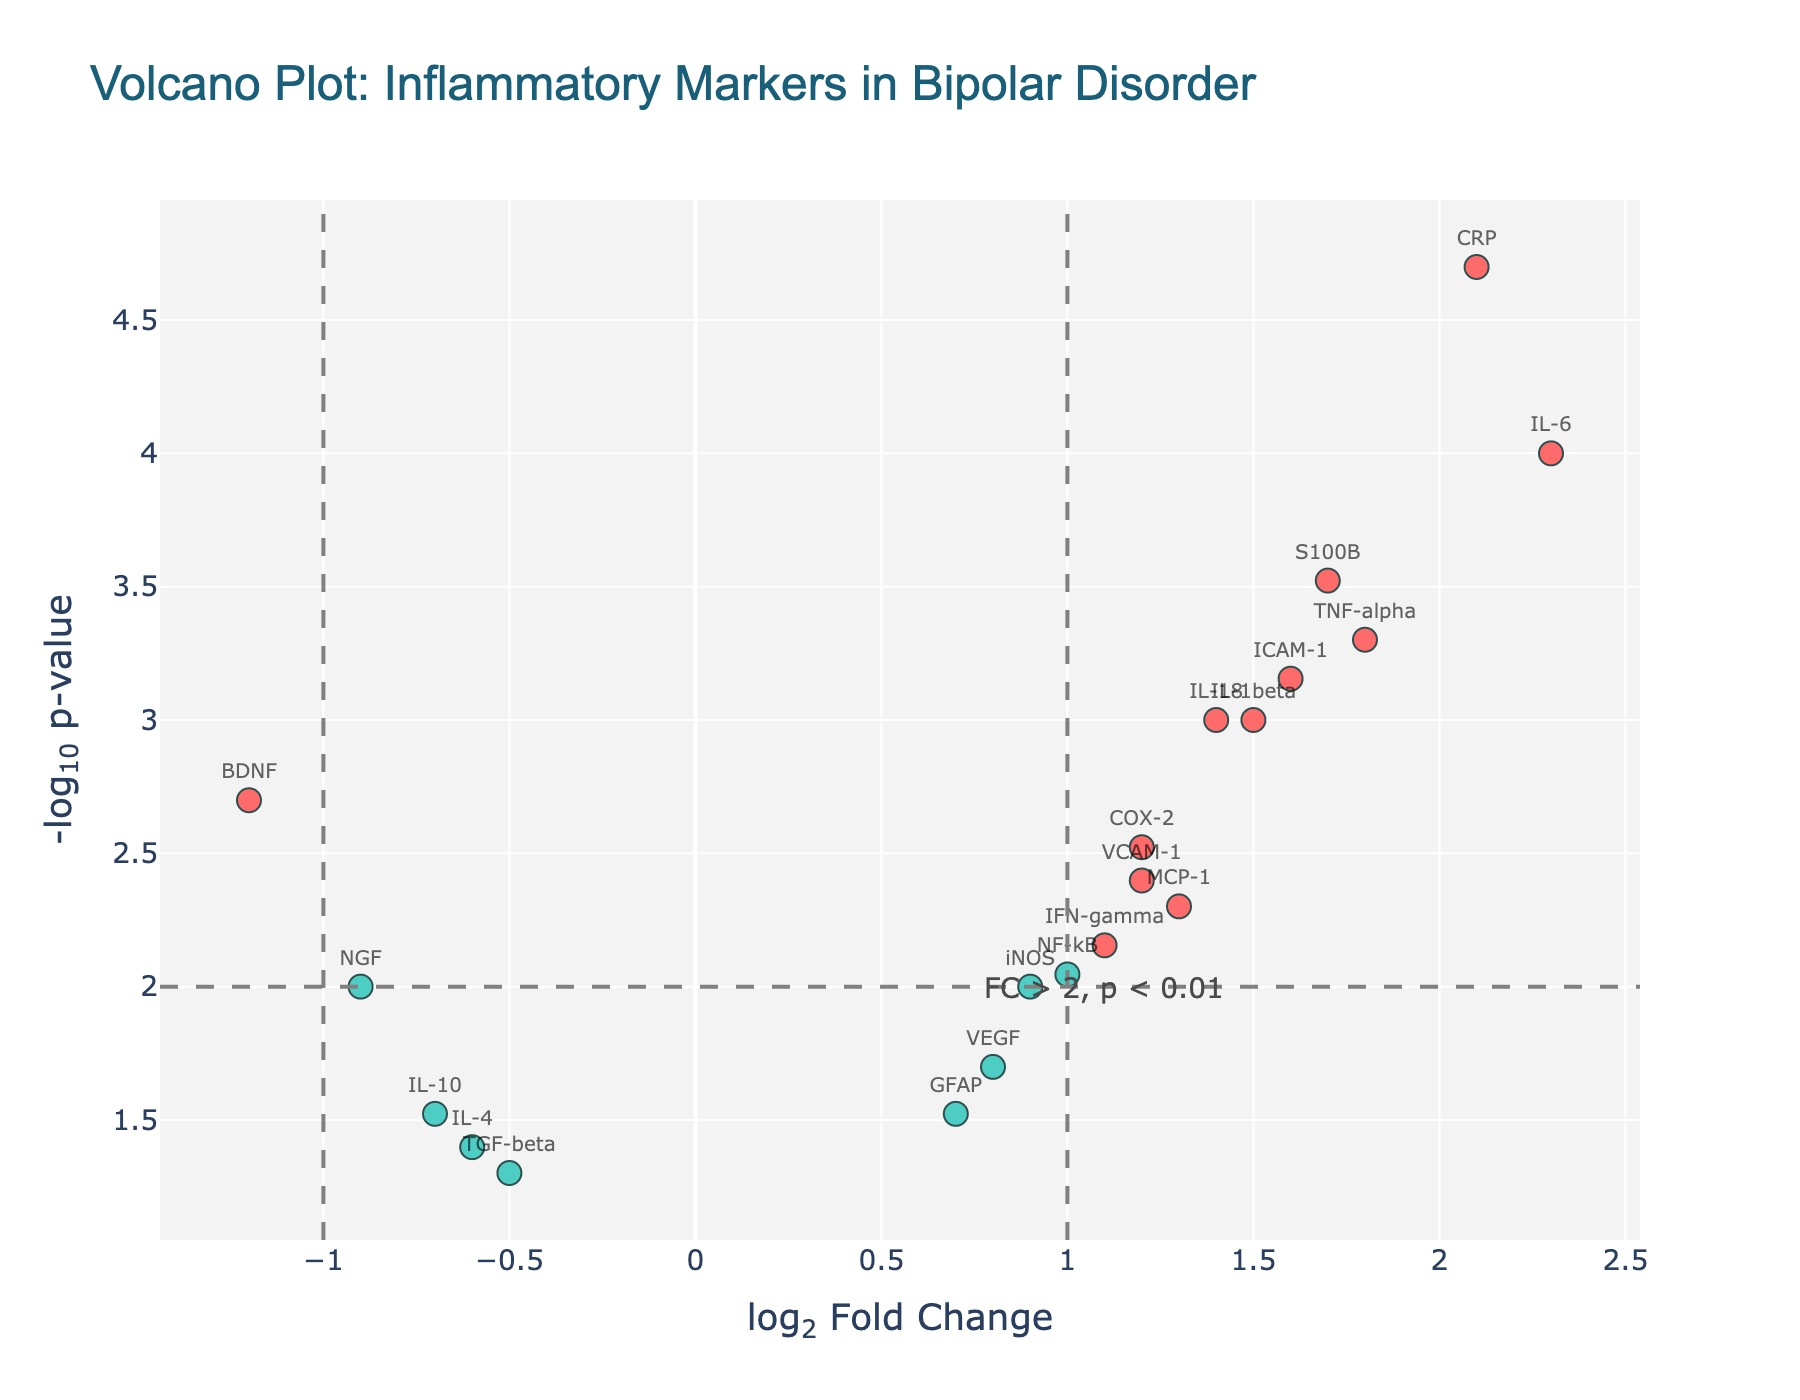What is the title of the figure? The title is located at the top center of the figure. It reads: "Volcano Plot: Inflammatory Markers in Bipolar Disorder".
Answer: Volcano Plot: Inflammatory Markers in Bipolar Disorder Which axis represents the log2 Fold Change? The x-axis is labeled "log<sub>2</sub> Fold Change". This label indicates that the x-axis represents the log2 fold change.
Answer: x-axis How many genes are identified as 'significant'? Significant genes are marked by red color dots, and the label in the figure says these have abs(log2FoldChange) > 1 and p-value < 0.01. By counting the red dots, we find there are 12 significant genes.
Answer: 12 Which gene has the highest positive log2 Fold Change, and what is its value? By examining the position of the dots on the x-axis, the highest positive log2 Fold Change is at 2.3, which corresponds to the IL-6 gene.
Answer: IL-6, 2.3 How many genes have a p-value less than 0.01? The horizontal threshold line for the p-value (y=-log10(0.01)) helps us identify genes below p=0.01. By counting dots above this line, we find there are 15 such genes.
Answer: 15 Which gene has the most negative log2 Fold Change, and what is its value? By examining the position of the dots on the x-axis, the most negative log2 Fold Change is at -1.2, which corresponds to the BDNF gene.
Answer: BDNF, -1.2 Which genes have log2 Fold Change greater than 1 and p-value less than 0.001? Significance criteria include having log2 Fold Change > 1 and p-value < 0.001. By matching these criteria, we find IL-6, CRP, S100B, and ICAM-1.
Answer: IL-6, CRP, S100B, ICAM-1 What is the p-value threshold line's y-coordinate value? The horizontal line represents the p-value threshold, which is -log10(0.01). Calculating -log10(0.01) yields 2.
Answer: 2 How many genes are located in the top-right quadrant of the plot (positive log2 Fold Change and p-value < 0.01)? The top-right quadrant includes positive log2 Fold Change and p-value < 0.01, denoted by red dots in this region. Counting these dots, there are 8 significant genes.
Answer: 8 